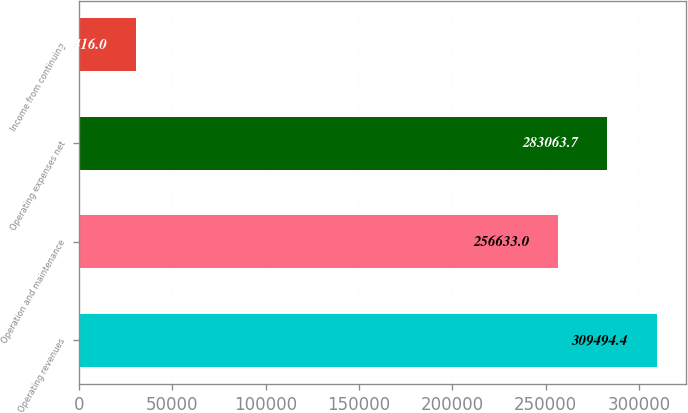Convert chart to OTSL. <chart><loc_0><loc_0><loc_500><loc_500><bar_chart><fcel>Operating revenues<fcel>Operation and maintenance<fcel>Operating expenses net<fcel>Income from continuing<nl><fcel>309494<fcel>256633<fcel>283064<fcel>30416<nl></chart> 